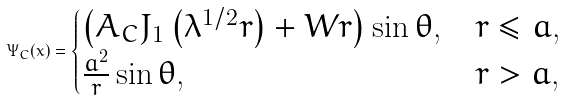Convert formula to latex. <formula><loc_0><loc_0><loc_500><loc_500>\Psi _ { C } ( x ) = \begin{cases} \left ( A _ { C } J _ { 1 } \left ( \lambda ^ { 1 / 2 } r \right ) + W r \right ) \sin \theta , & r \leq a , \\ \frac { a ^ { 2 } } { r } \sin \theta , & r > a , \end{cases}</formula> 